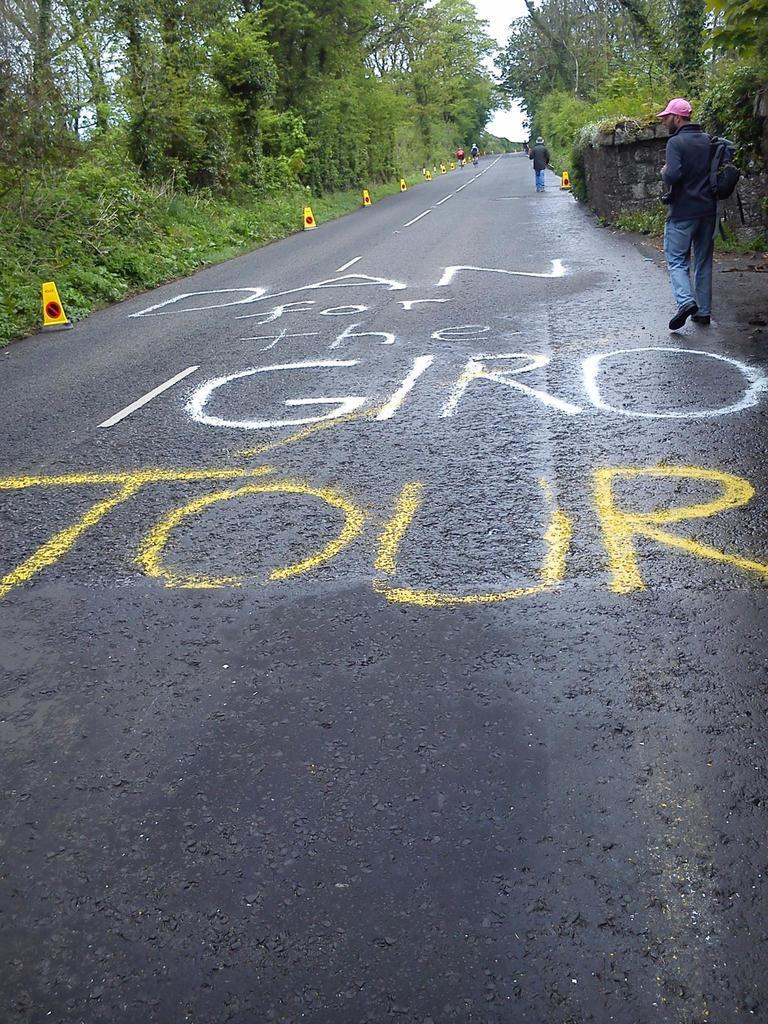What can be seen in the sky in the image? The sky is visible in the image. What type of natural elements are present in the image? There are trees and plants in the image. What type of infrastructure is present in the image? Traffic equipment is placed on the sides of the road. Are there any living beings in the image? Yes, people are present in the image. What is written on the road in the image? There is something written on the road. What type of bread is being digested by the people in the image? There is no bread or digestion process depicted in the image. How many cherries are being held by the trees in the image? There are no cherries present in the image; it features trees and plants, but not specifically cherry trees. 